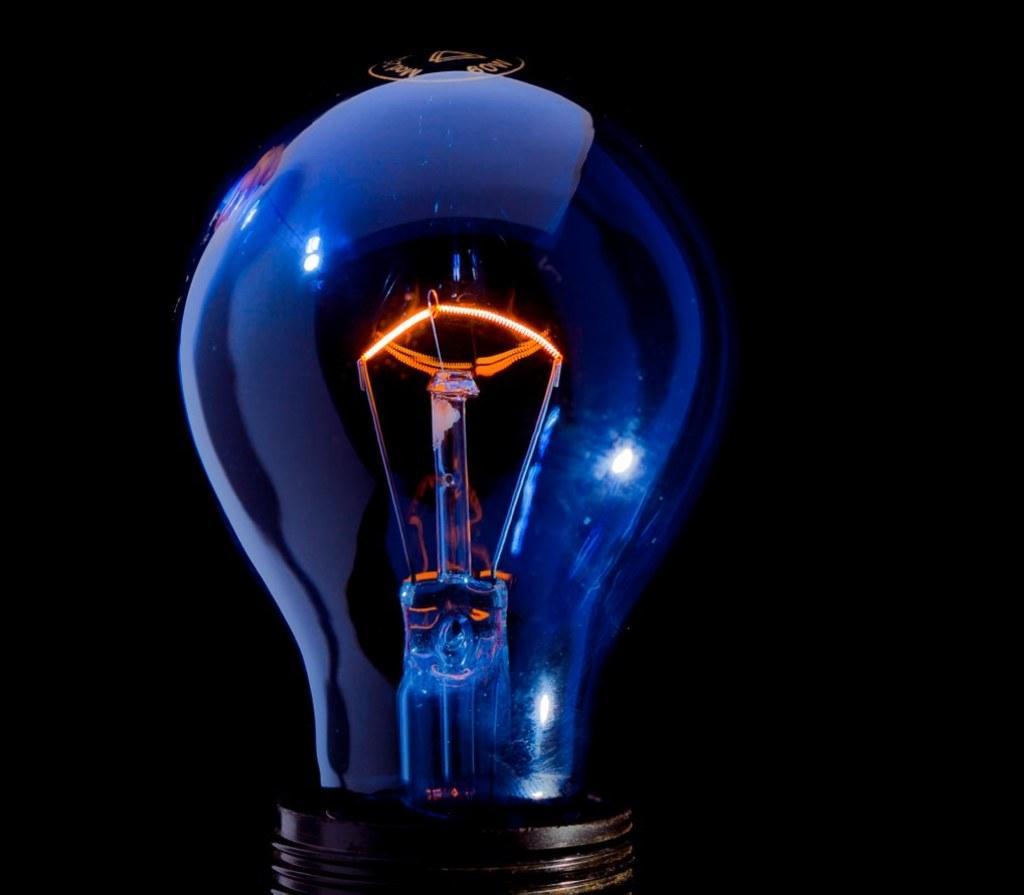Could you give a brief overview of what you see in this image? In this image there is a bulb. 